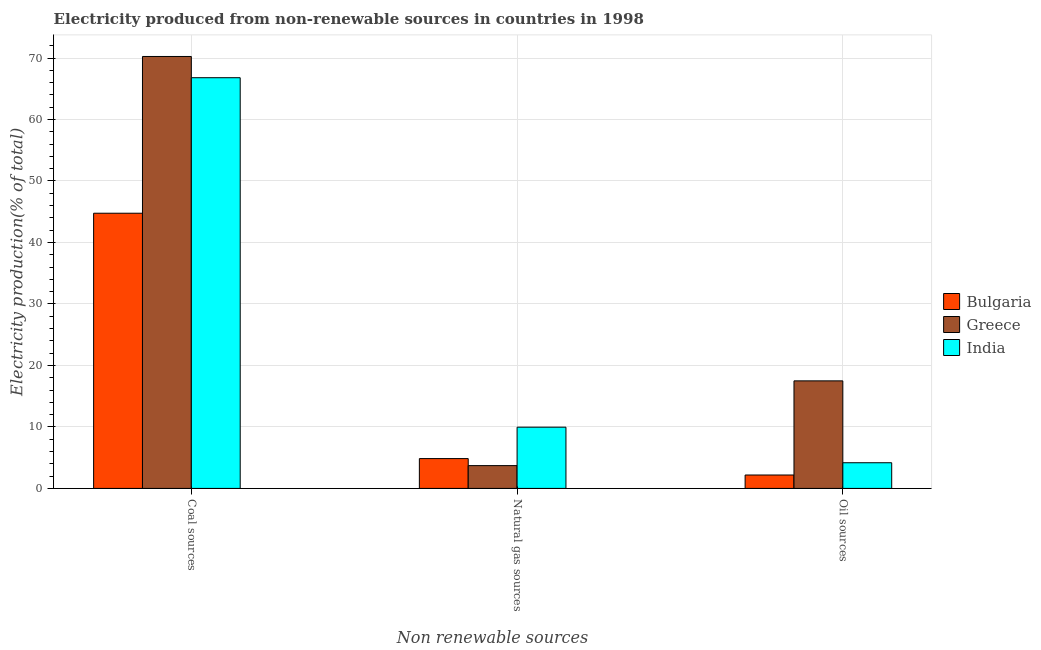How many different coloured bars are there?
Keep it short and to the point. 3. How many groups of bars are there?
Provide a short and direct response. 3. What is the label of the 2nd group of bars from the left?
Your answer should be compact. Natural gas sources. What is the percentage of electricity produced by coal in Greece?
Offer a terse response. 70.25. Across all countries, what is the maximum percentage of electricity produced by natural gas?
Make the answer very short. 9.96. Across all countries, what is the minimum percentage of electricity produced by coal?
Provide a short and direct response. 44.76. What is the total percentage of electricity produced by coal in the graph?
Offer a very short reply. 181.81. What is the difference between the percentage of electricity produced by natural gas in Bulgaria and that in India?
Your response must be concise. -5.11. What is the difference between the percentage of electricity produced by coal in Bulgaria and the percentage of electricity produced by natural gas in Greece?
Offer a terse response. 41.05. What is the average percentage of electricity produced by coal per country?
Your answer should be compact. 60.6. What is the difference between the percentage of electricity produced by natural gas and percentage of electricity produced by coal in Greece?
Your answer should be compact. -66.54. In how many countries, is the percentage of electricity produced by natural gas greater than 44 %?
Make the answer very short. 0. What is the ratio of the percentage of electricity produced by coal in Greece to that in Bulgaria?
Give a very brief answer. 1.57. What is the difference between the highest and the second highest percentage of electricity produced by natural gas?
Offer a terse response. 5.11. What is the difference between the highest and the lowest percentage of electricity produced by oil sources?
Your answer should be very brief. 15.31. Is the sum of the percentage of electricity produced by coal in Bulgaria and Greece greater than the maximum percentage of electricity produced by natural gas across all countries?
Provide a short and direct response. Yes. What does the 3rd bar from the left in Oil sources represents?
Make the answer very short. India. What does the 2nd bar from the right in Oil sources represents?
Your response must be concise. Greece. How many countries are there in the graph?
Provide a succinct answer. 3. Are the values on the major ticks of Y-axis written in scientific E-notation?
Keep it short and to the point. No. Does the graph contain any zero values?
Offer a terse response. No. Does the graph contain grids?
Your answer should be very brief. Yes. How are the legend labels stacked?
Your answer should be compact. Vertical. What is the title of the graph?
Provide a succinct answer. Electricity produced from non-renewable sources in countries in 1998. Does "Swaziland" appear as one of the legend labels in the graph?
Offer a terse response. No. What is the label or title of the X-axis?
Give a very brief answer. Non renewable sources. What is the Electricity production(% of total) in Bulgaria in Coal sources?
Make the answer very short. 44.76. What is the Electricity production(% of total) of Greece in Coal sources?
Offer a terse response. 70.25. What is the Electricity production(% of total) of India in Coal sources?
Provide a short and direct response. 66.8. What is the Electricity production(% of total) in Bulgaria in Natural gas sources?
Your answer should be very brief. 4.85. What is the Electricity production(% of total) of Greece in Natural gas sources?
Your answer should be very brief. 3.71. What is the Electricity production(% of total) in India in Natural gas sources?
Offer a terse response. 9.96. What is the Electricity production(% of total) in Bulgaria in Oil sources?
Offer a terse response. 2.18. What is the Electricity production(% of total) of Greece in Oil sources?
Your answer should be compact. 17.49. What is the Electricity production(% of total) of India in Oil sources?
Provide a short and direct response. 4.18. Across all Non renewable sources, what is the maximum Electricity production(% of total) in Bulgaria?
Provide a succinct answer. 44.76. Across all Non renewable sources, what is the maximum Electricity production(% of total) of Greece?
Make the answer very short. 70.25. Across all Non renewable sources, what is the maximum Electricity production(% of total) of India?
Offer a terse response. 66.8. Across all Non renewable sources, what is the minimum Electricity production(% of total) of Bulgaria?
Make the answer very short. 2.18. Across all Non renewable sources, what is the minimum Electricity production(% of total) of Greece?
Your answer should be compact. 3.71. Across all Non renewable sources, what is the minimum Electricity production(% of total) of India?
Make the answer very short. 4.18. What is the total Electricity production(% of total) in Bulgaria in the graph?
Keep it short and to the point. 51.79. What is the total Electricity production(% of total) in Greece in the graph?
Provide a succinct answer. 91.45. What is the total Electricity production(% of total) of India in the graph?
Provide a short and direct response. 80.93. What is the difference between the Electricity production(% of total) of Bulgaria in Coal sources and that in Natural gas sources?
Offer a terse response. 39.91. What is the difference between the Electricity production(% of total) of Greece in Coal sources and that in Natural gas sources?
Provide a short and direct response. 66.54. What is the difference between the Electricity production(% of total) of India in Coal sources and that in Natural gas sources?
Provide a short and direct response. 56.84. What is the difference between the Electricity production(% of total) in Bulgaria in Coal sources and that in Oil sources?
Offer a very short reply. 42.58. What is the difference between the Electricity production(% of total) of Greece in Coal sources and that in Oil sources?
Offer a terse response. 52.76. What is the difference between the Electricity production(% of total) in India in Coal sources and that in Oil sources?
Offer a very short reply. 62.62. What is the difference between the Electricity production(% of total) of Bulgaria in Natural gas sources and that in Oil sources?
Offer a terse response. 2.67. What is the difference between the Electricity production(% of total) of Greece in Natural gas sources and that in Oil sources?
Your answer should be very brief. -13.78. What is the difference between the Electricity production(% of total) in India in Natural gas sources and that in Oil sources?
Keep it short and to the point. 5.78. What is the difference between the Electricity production(% of total) in Bulgaria in Coal sources and the Electricity production(% of total) in Greece in Natural gas sources?
Your response must be concise. 41.05. What is the difference between the Electricity production(% of total) of Bulgaria in Coal sources and the Electricity production(% of total) of India in Natural gas sources?
Give a very brief answer. 34.8. What is the difference between the Electricity production(% of total) in Greece in Coal sources and the Electricity production(% of total) in India in Natural gas sources?
Ensure brevity in your answer.  60.29. What is the difference between the Electricity production(% of total) of Bulgaria in Coal sources and the Electricity production(% of total) of Greece in Oil sources?
Offer a terse response. 27.27. What is the difference between the Electricity production(% of total) in Bulgaria in Coal sources and the Electricity production(% of total) in India in Oil sources?
Your answer should be very brief. 40.58. What is the difference between the Electricity production(% of total) of Greece in Coal sources and the Electricity production(% of total) of India in Oil sources?
Give a very brief answer. 66.08. What is the difference between the Electricity production(% of total) of Bulgaria in Natural gas sources and the Electricity production(% of total) of Greece in Oil sources?
Offer a terse response. -12.64. What is the difference between the Electricity production(% of total) of Bulgaria in Natural gas sources and the Electricity production(% of total) of India in Oil sources?
Your answer should be very brief. 0.68. What is the difference between the Electricity production(% of total) of Greece in Natural gas sources and the Electricity production(% of total) of India in Oil sources?
Provide a short and direct response. -0.47. What is the average Electricity production(% of total) of Bulgaria per Non renewable sources?
Give a very brief answer. 17.26. What is the average Electricity production(% of total) of Greece per Non renewable sources?
Your answer should be very brief. 30.48. What is the average Electricity production(% of total) of India per Non renewable sources?
Provide a succinct answer. 26.98. What is the difference between the Electricity production(% of total) of Bulgaria and Electricity production(% of total) of Greece in Coal sources?
Your answer should be very brief. -25.49. What is the difference between the Electricity production(% of total) in Bulgaria and Electricity production(% of total) in India in Coal sources?
Keep it short and to the point. -22.04. What is the difference between the Electricity production(% of total) in Greece and Electricity production(% of total) in India in Coal sources?
Give a very brief answer. 3.46. What is the difference between the Electricity production(% of total) of Bulgaria and Electricity production(% of total) of Greece in Natural gas sources?
Provide a succinct answer. 1.14. What is the difference between the Electricity production(% of total) in Bulgaria and Electricity production(% of total) in India in Natural gas sources?
Keep it short and to the point. -5.11. What is the difference between the Electricity production(% of total) in Greece and Electricity production(% of total) in India in Natural gas sources?
Provide a short and direct response. -6.25. What is the difference between the Electricity production(% of total) in Bulgaria and Electricity production(% of total) in Greece in Oil sources?
Provide a succinct answer. -15.31. What is the difference between the Electricity production(% of total) of Bulgaria and Electricity production(% of total) of India in Oil sources?
Provide a succinct answer. -1.99. What is the difference between the Electricity production(% of total) of Greece and Electricity production(% of total) of India in Oil sources?
Your answer should be compact. 13.32. What is the ratio of the Electricity production(% of total) of Bulgaria in Coal sources to that in Natural gas sources?
Give a very brief answer. 9.22. What is the ratio of the Electricity production(% of total) of Greece in Coal sources to that in Natural gas sources?
Make the answer very short. 18.94. What is the ratio of the Electricity production(% of total) in India in Coal sources to that in Natural gas sources?
Provide a short and direct response. 6.71. What is the ratio of the Electricity production(% of total) in Bulgaria in Coal sources to that in Oil sources?
Give a very brief answer. 20.52. What is the ratio of the Electricity production(% of total) in Greece in Coal sources to that in Oil sources?
Make the answer very short. 4.02. What is the ratio of the Electricity production(% of total) of India in Coal sources to that in Oil sources?
Your response must be concise. 15.99. What is the ratio of the Electricity production(% of total) of Bulgaria in Natural gas sources to that in Oil sources?
Offer a terse response. 2.22. What is the ratio of the Electricity production(% of total) of Greece in Natural gas sources to that in Oil sources?
Your answer should be very brief. 0.21. What is the ratio of the Electricity production(% of total) in India in Natural gas sources to that in Oil sources?
Give a very brief answer. 2.39. What is the difference between the highest and the second highest Electricity production(% of total) in Bulgaria?
Keep it short and to the point. 39.91. What is the difference between the highest and the second highest Electricity production(% of total) in Greece?
Your answer should be very brief. 52.76. What is the difference between the highest and the second highest Electricity production(% of total) of India?
Your response must be concise. 56.84. What is the difference between the highest and the lowest Electricity production(% of total) in Bulgaria?
Offer a terse response. 42.58. What is the difference between the highest and the lowest Electricity production(% of total) in Greece?
Offer a very short reply. 66.54. What is the difference between the highest and the lowest Electricity production(% of total) of India?
Make the answer very short. 62.62. 